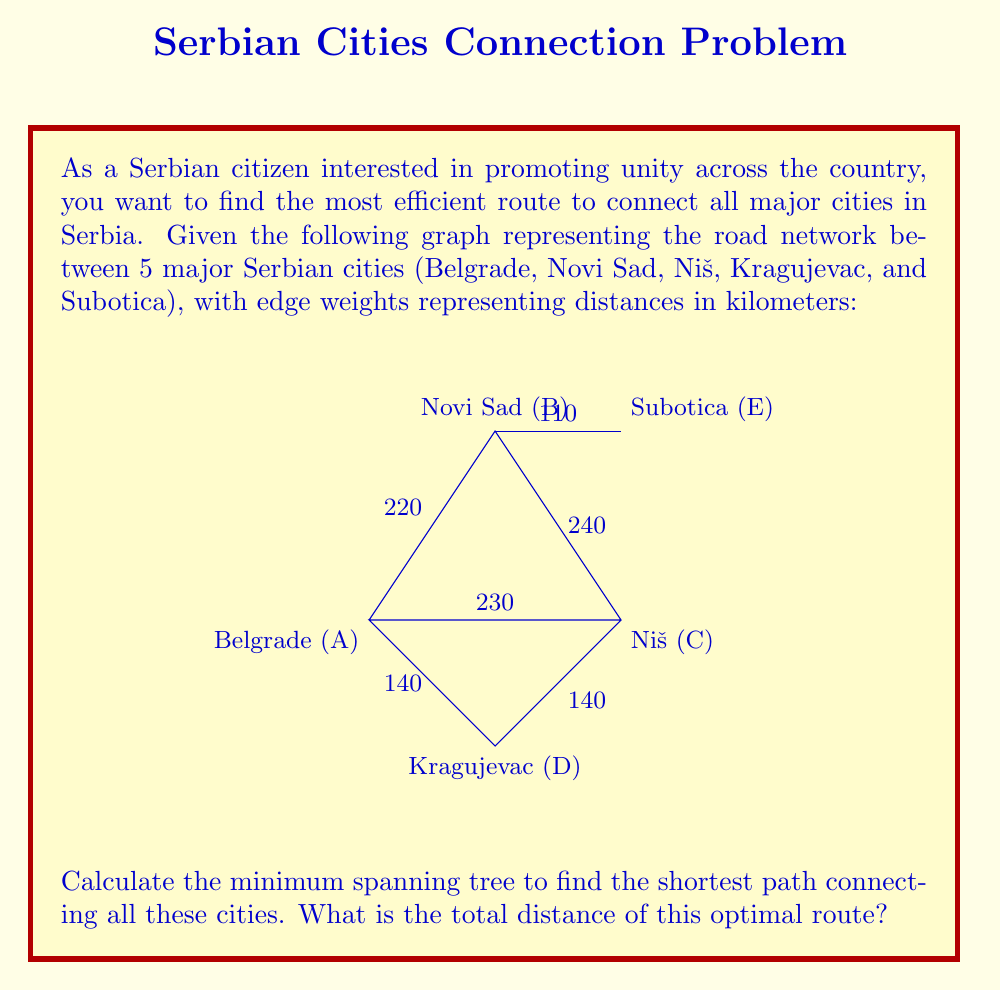What is the answer to this math problem? To find the shortest path connecting all cities, we need to calculate the minimum spanning tree (MST) of the given graph. We'll use Kruskal's algorithm to find the MST:

1. Sort all edges by weight (distance) in ascending order:
   $$(B,E): 110 \text{ km}$$
   $$(A,D): 140 \text{ km}$$
   $$(C,D): 140 \text{ km}$$
   $$(A,B): 220 \text{ km}$$
   $$(A,C): 230 \text{ km}$$
   $$(B,C): 240 \text{ km}$$

2. Start with an empty MST and add edges in order, skipping those that would create a cycle:
   - Add $(B,E): 110 \text{ km}$
   - Add $(A,D): 140 \text{ km}$
   - Add $(C,D): 140 \text{ km}$
   - Add $(A,B): 220 \text{ km}$

3. After adding these edges, we have connected all vertices (cities) without creating any cycles. The MST is complete.

4. Calculate the total distance by summing the weights of the selected edges:
   $$110 + 140 + 140 + 220 = 610 \text{ km}$$

Therefore, the shortest path connecting all major cities in Serbia has a total distance of 610 km.
Answer: 610 km 